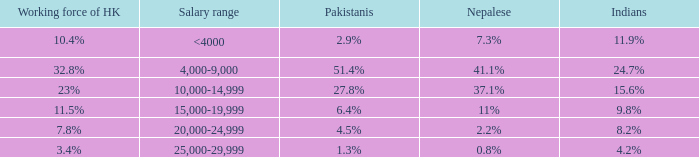Can you parse all the data within this table? {'header': ['Working force of HK', 'Salary range', 'Pakistanis', 'Nepalese', 'Indians'], 'rows': [['10.4%', '<4000', '2.9%', '7.3%', '11.9%'], ['32.8%', '4,000-9,000', '51.4%', '41.1%', '24.7%'], ['23%', '10,000-14,999', '27.8%', '37.1%', '15.6%'], ['11.5%', '15,000-19,999', '6.4%', '11%', '9.8%'], ['7.8%', '20,000-24,999', '4.5%', '2.2%', '8.2%'], ['3.4%', '25,000-29,999', '1.3%', '0.8%', '4.2%']]} If the nepalese is 37.1%, what is the working force of HK? 23%. 